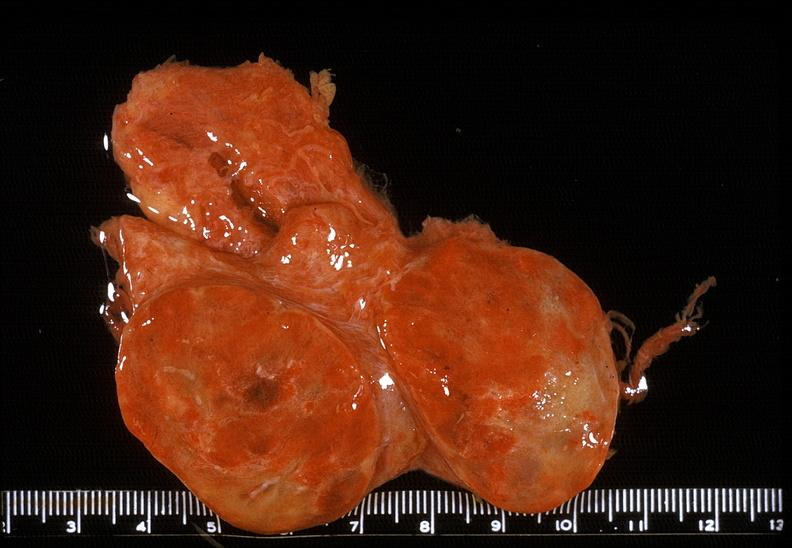s endocrine present?
Answer the question using a single word or phrase. Yes 